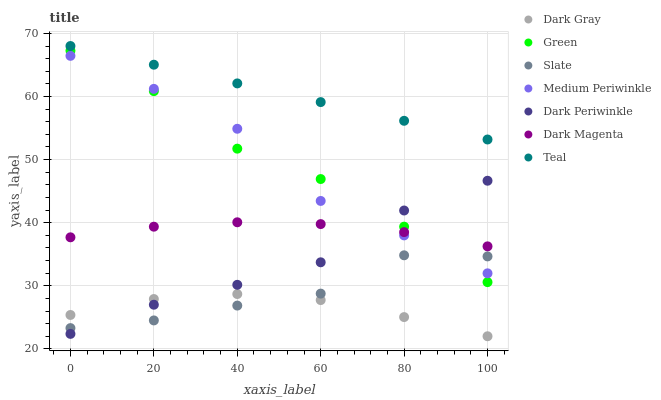Does Dark Gray have the minimum area under the curve?
Answer yes or no. Yes. Does Teal have the maximum area under the curve?
Answer yes or no. Yes. Does Slate have the minimum area under the curve?
Answer yes or no. No. Does Slate have the maximum area under the curve?
Answer yes or no. No. Is Teal the smoothest?
Answer yes or no. Yes. Is Medium Periwinkle the roughest?
Answer yes or no. Yes. Is Slate the smoothest?
Answer yes or no. No. Is Slate the roughest?
Answer yes or no. No. Does Dark Gray have the lowest value?
Answer yes or no. Yes. Does Slate have the lowest value?
Answer yes or no. No. Does Teal have the highest value?
Answer yes or no. Yes. Does Slate have the highest value?
Answer yes or no. No. Is Dark Gray less than Dark Magenta?
Answer yes or no. Yes. Is Teal greater than Dark Magenta?
Answer yes or no. Yes. Does Green intersect Dark Periwinkle?
Answer yes or no. Yes. Is Green less than Dark Periwinkle?
Answer yes or no. No. Is Green greater than Dark Periwinkle?
Answer yes or no. No. Does Dark Gray intersect Dark Magenta?
Answer yes or no. No. 